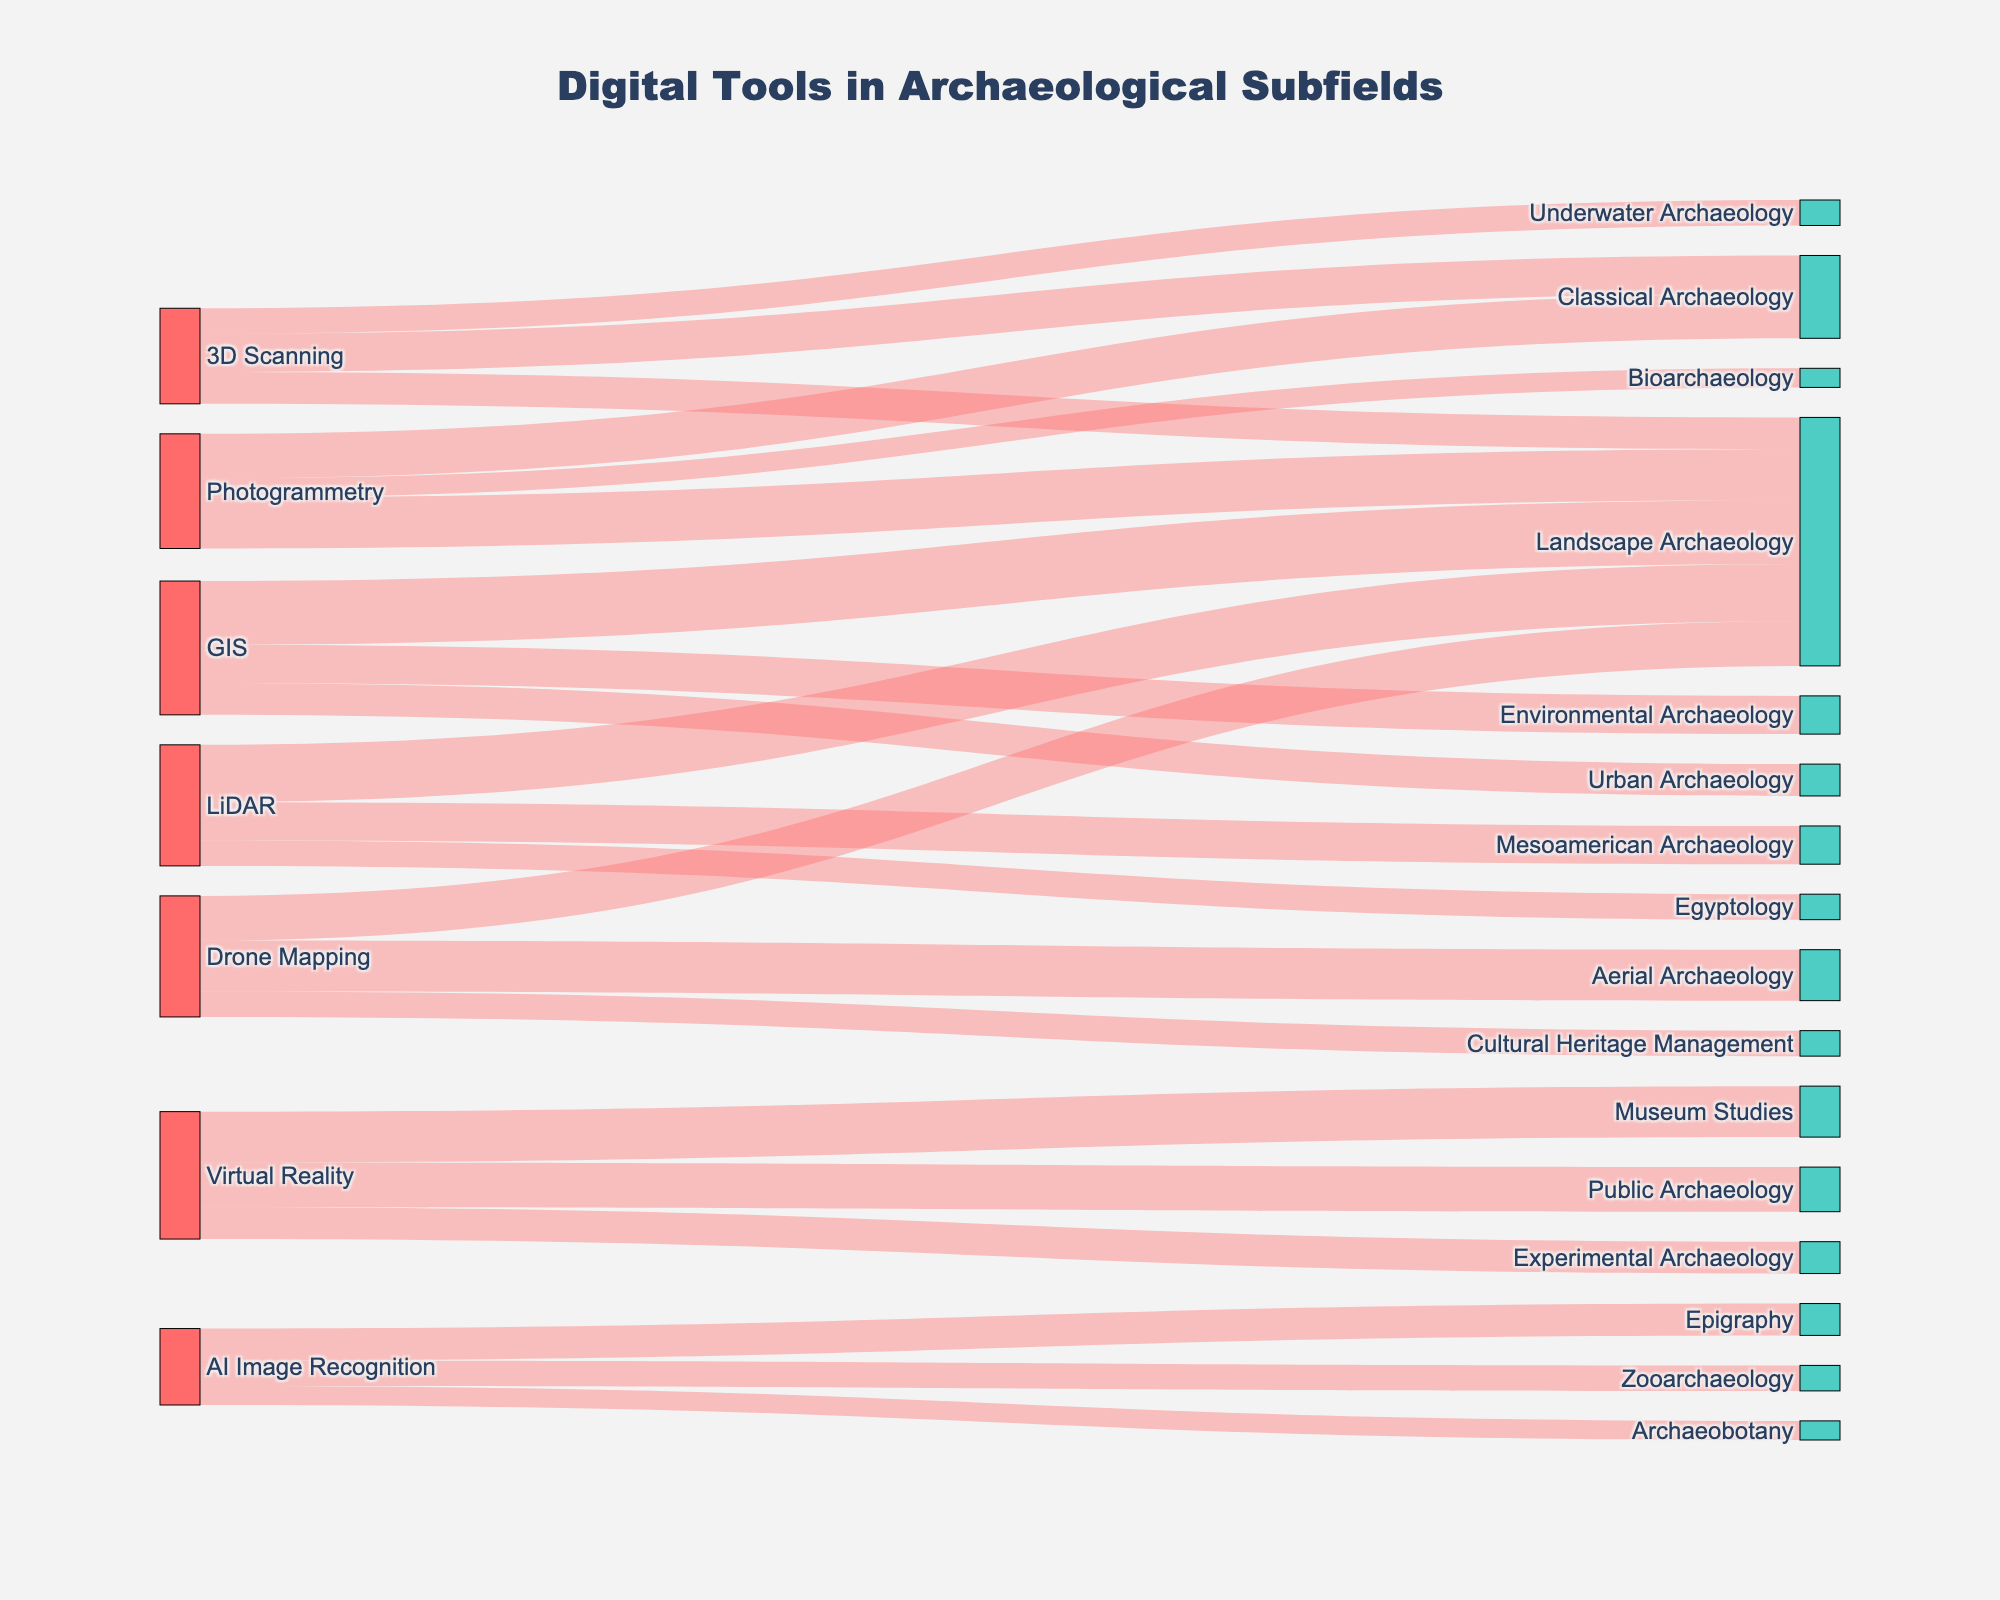What's the title of the figure? The title is situated at the top of the figure. It generally summarizes the overall content or focus of the figure.
Answer: Digital Tools in Archaeological Subfields Which digital tool is connected to the highest number of subfields? By counting the connections from each digital tool to various subfields in the figure, we can determine which tool has the most links.
Answer: Photogrammetry How many links are there between digital tools and subfields? Counting all connections between digital tools and subfields will give the total number of links.
Answer: 22 What subfield receives the most connections from different digital tools? By observing the subfields on the right side of the figure and counting the number of incoming connections for each subfield, we find the one with the most.
Answer: Landscape Archaeology Which digital tool is most frequently used in Landscape Archaeology? By examining the connections to Landscape Archaeology from different digital tools and comparing their values, we can identify the most frequently used tool.
Answer: GIS What is the total value of digital tools used in Classical Archaeology? Summing the values of links from all digital tools to Classical Archaeology provides the total usage value.
Answer: 65 How does the usage of Virtual Reality compare between Experimental Archaeology and Museum Studies? Comparing the values of the connections from Virtual Reality to Experimental Archaeology and Museum Studies shows the relative usage.
Answer: Museum Studies has higher usage What is the total number of connections for 3D Scanning and LiDAR combined? By counting the connections from 3D Scanning and LiDAR and then adding them together, we get the total number of connections.
Answer: 6 Which subfield has the least number of connections and what are they? By identifying the subfield with the fewest incoming links and listing these connections, we find the answer.
Answer: Bioarchaeology, with 1 connection (Photogrammetry) Between GIS and Drone Mapping, which digital tool has more varied usage across different subfields? By comparing the number of different subfields each tool is connected to, we find out which has more varied usage.
Answer: GIS 